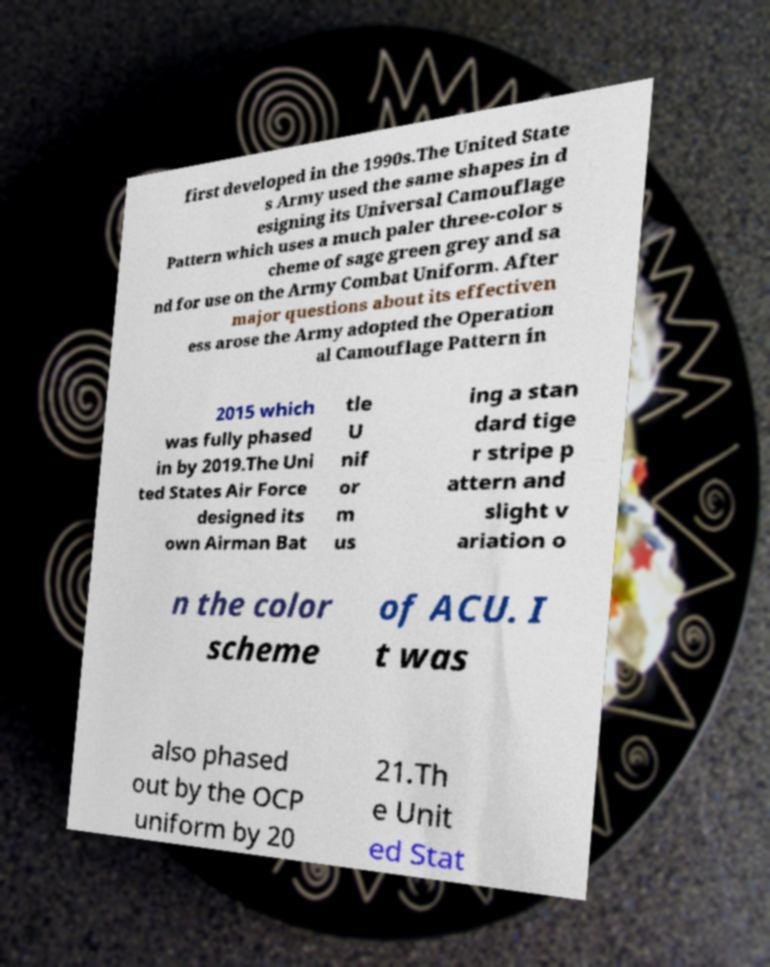For documentation purposes, I need the text within this image transcribed. Could you provide that? first developed in the 1990s.The United State s Army used the same shapes in d esigning its Universal Camouflage Pattern which uses a much paler three-color s cheme of sage green grey and sa nd for use on the Army Combat Uniform. After major questions about its effectiven ess arose the Army adopted the Operation al Camouflage Pattern in 2015 which was fully phased in by 2019.The Uni ted States Air Force designed its own Airman Bat tle U nif or m us ing a stan dard tige r stripe p attern and slight v ariation o n the color scheme of ACU. I t was also phased out by the OCP uniform by 20 21.Th e Unit ed Stat 